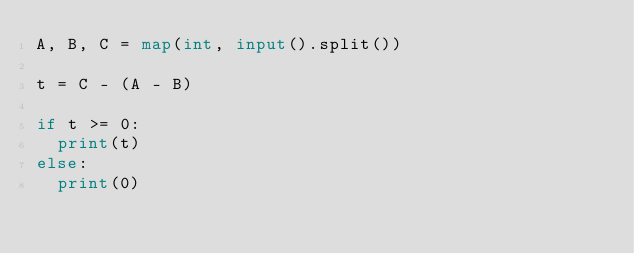<code> <loc_0><loc_0><loc_500><loc_500><_Python_>A, B, C = map(int, input().split())

t = C - (A - B)

if t >= 0:
  print(t)
else:
  print(0)</code> 